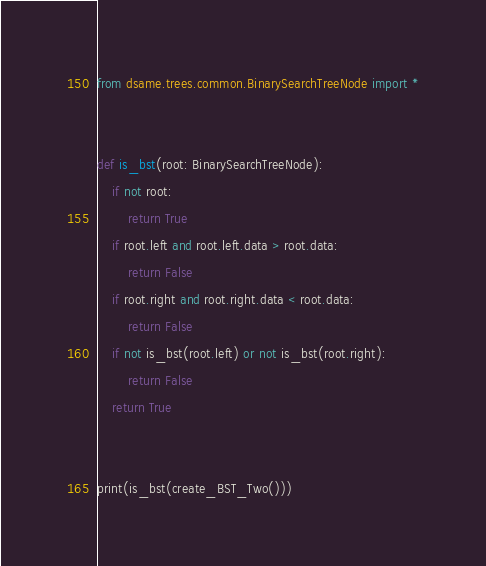Convert code to text. <code><loc_0><loc_0><loc_500><loc_500><_Python_>from dsame.trees.common.BinarySearchTreeNode import *


def is_bst(root: BinarySearchTreeNode):
    if not root:
        return True
    if root.left and root.left.data > root.data:
        return False
    if root.right and root.right.data < root.data:
        return False
    if not is_bst(root.left) or not is_bst(root.right):
        return False
    return True


print(is_bst(create_BST_Two()))
</code> 